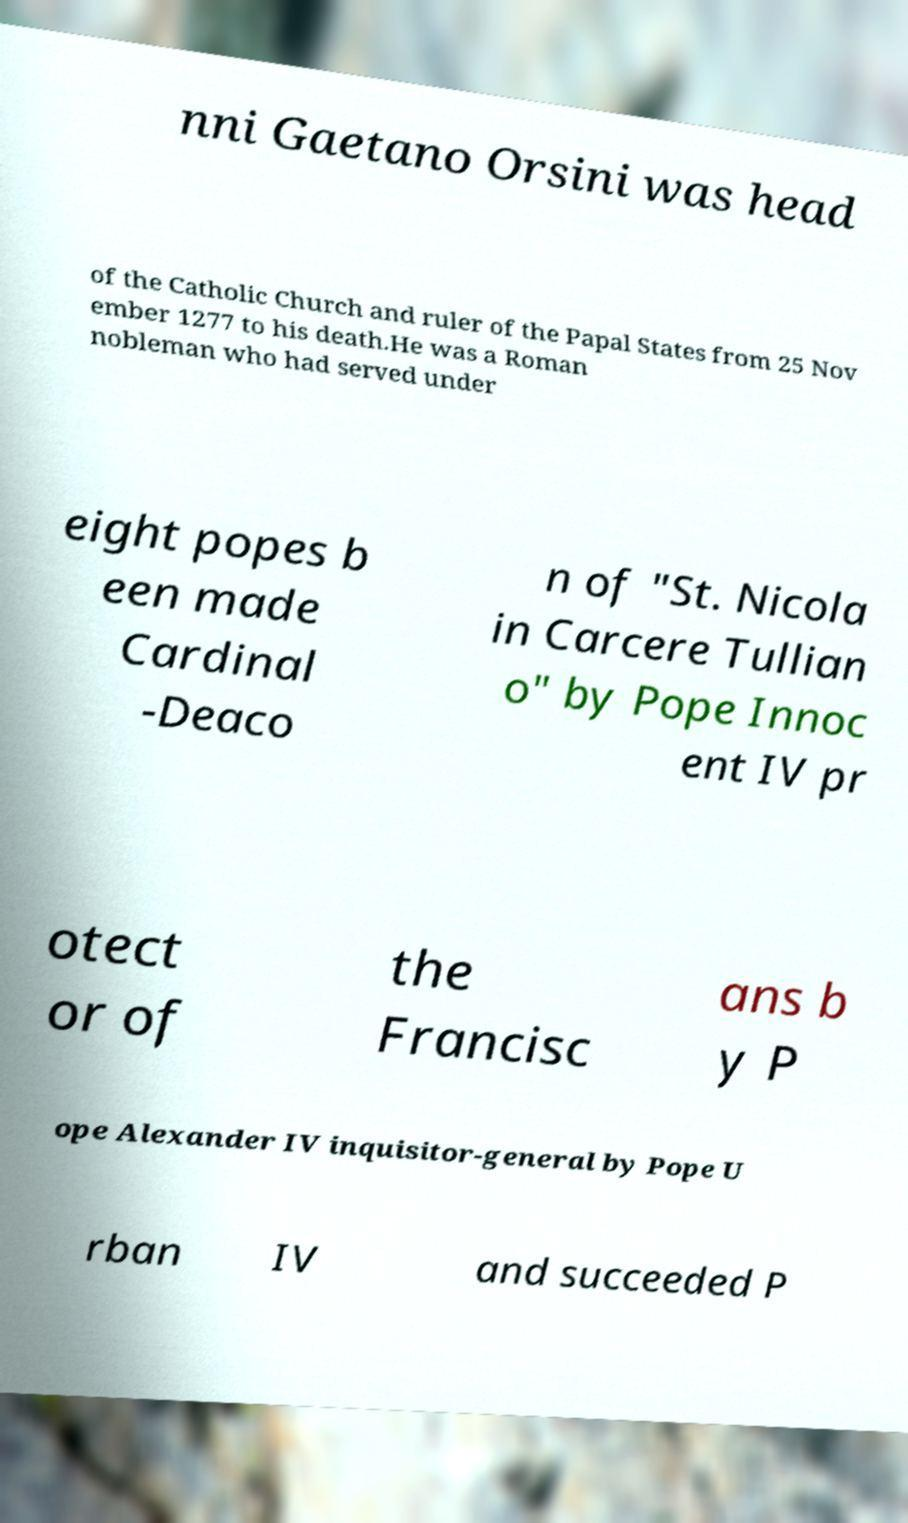Please identify and transcribe the text found in this image. nni Gaetano Orsini was head of the Catholic Church and ruler of the Papal States from 25 Nov ember 1277 to his death.He was a Roman nobleman who had served under eight popes b een made Cardinal -Deaco n of "St. Nicola in Carcere Tullian o" by Pope Innoc ent IV pr otect or of the Francisc ans b y P ope Alexander IV inquisitor-general by Pope U rban IV and succeeded P 